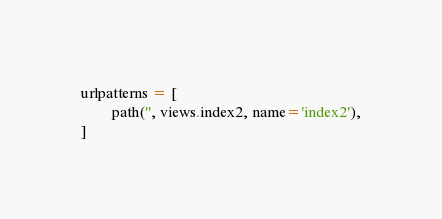<code> <loc_0><loc_0><loc_500><loc_500><_Python_>
urlpatterns = [
        path('', views.index2, name='index2'),
]
</code> 